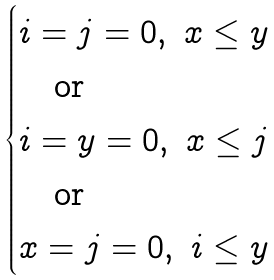Convert formula to latex. <formula><loc_0><loc_0><loc_500><loc_500>\begin{cases} i = j = 0 , \ x \leq y \\ \quad \text {or} \\ i = y = 0 , \ x \leq j \\ \quad \text {or} \\ x = j = 0 , \ i \leq y \\ \end{cases}</formula> 